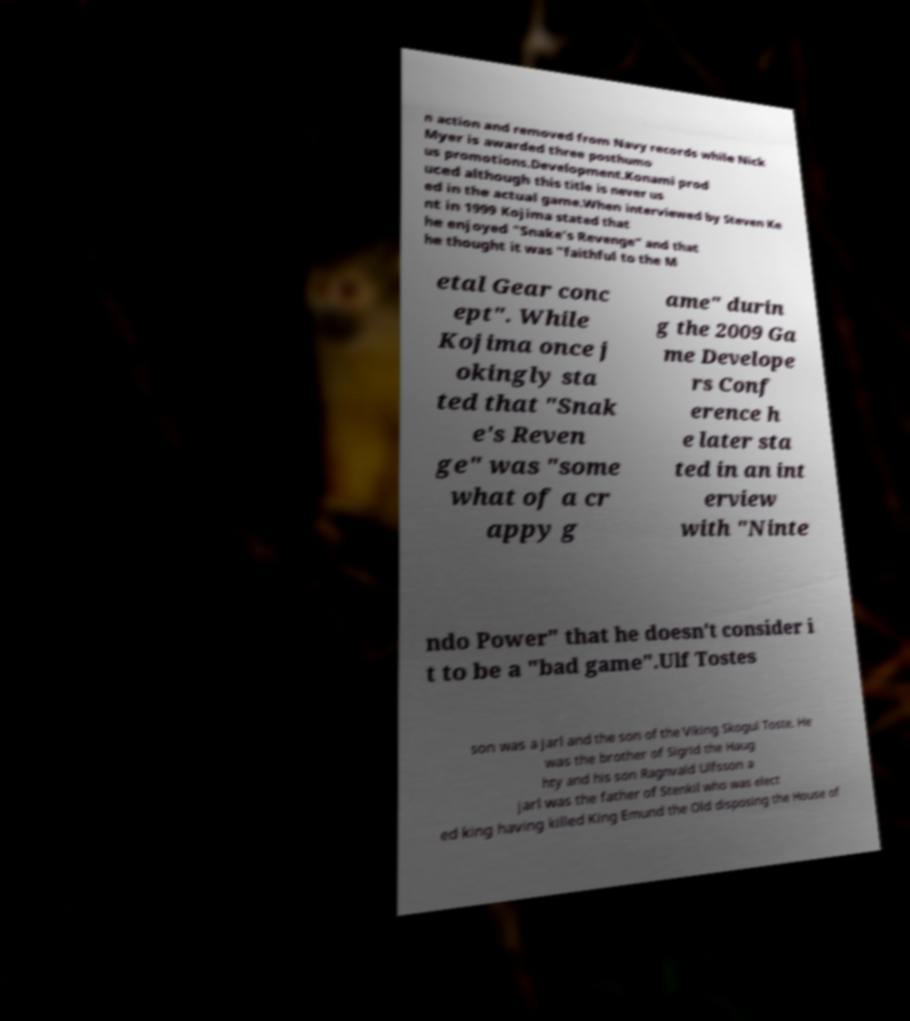Can you read and provide the text displayed in the image?This photo seems to have some interesting text. Can you extract and type it out for me? n action and removed from Navy records while Nick Myer is awarded three posthumo us promotions.Development.Konami prod uced although this title is never us ed in the actual game.When interviewed by Steven Ke nt in 1999 Kojima stated that he enjoyed "Snake's Revenge" and that he thought it was "faithful to the M etal Gear conc ept". While Kojima once j okingly sta ted that "Snak e's Reven ge" was "some what of a cr appy g ame" durin g the 2009 Ga me Develope rs Conf erence h e later sta ted in an int erview with "Ninte ndo Power" that he doesn't consider i t to be a "bad game".Ulf Tostes son was a jarl and the son of the Viking Skogul Toste. He was the brother of Sigrid the Haug hty and his son Ragnvald Ulfsson a jarl was the father of Stenkil who was elect ed king having killed King Emund the Old disposing the House of 